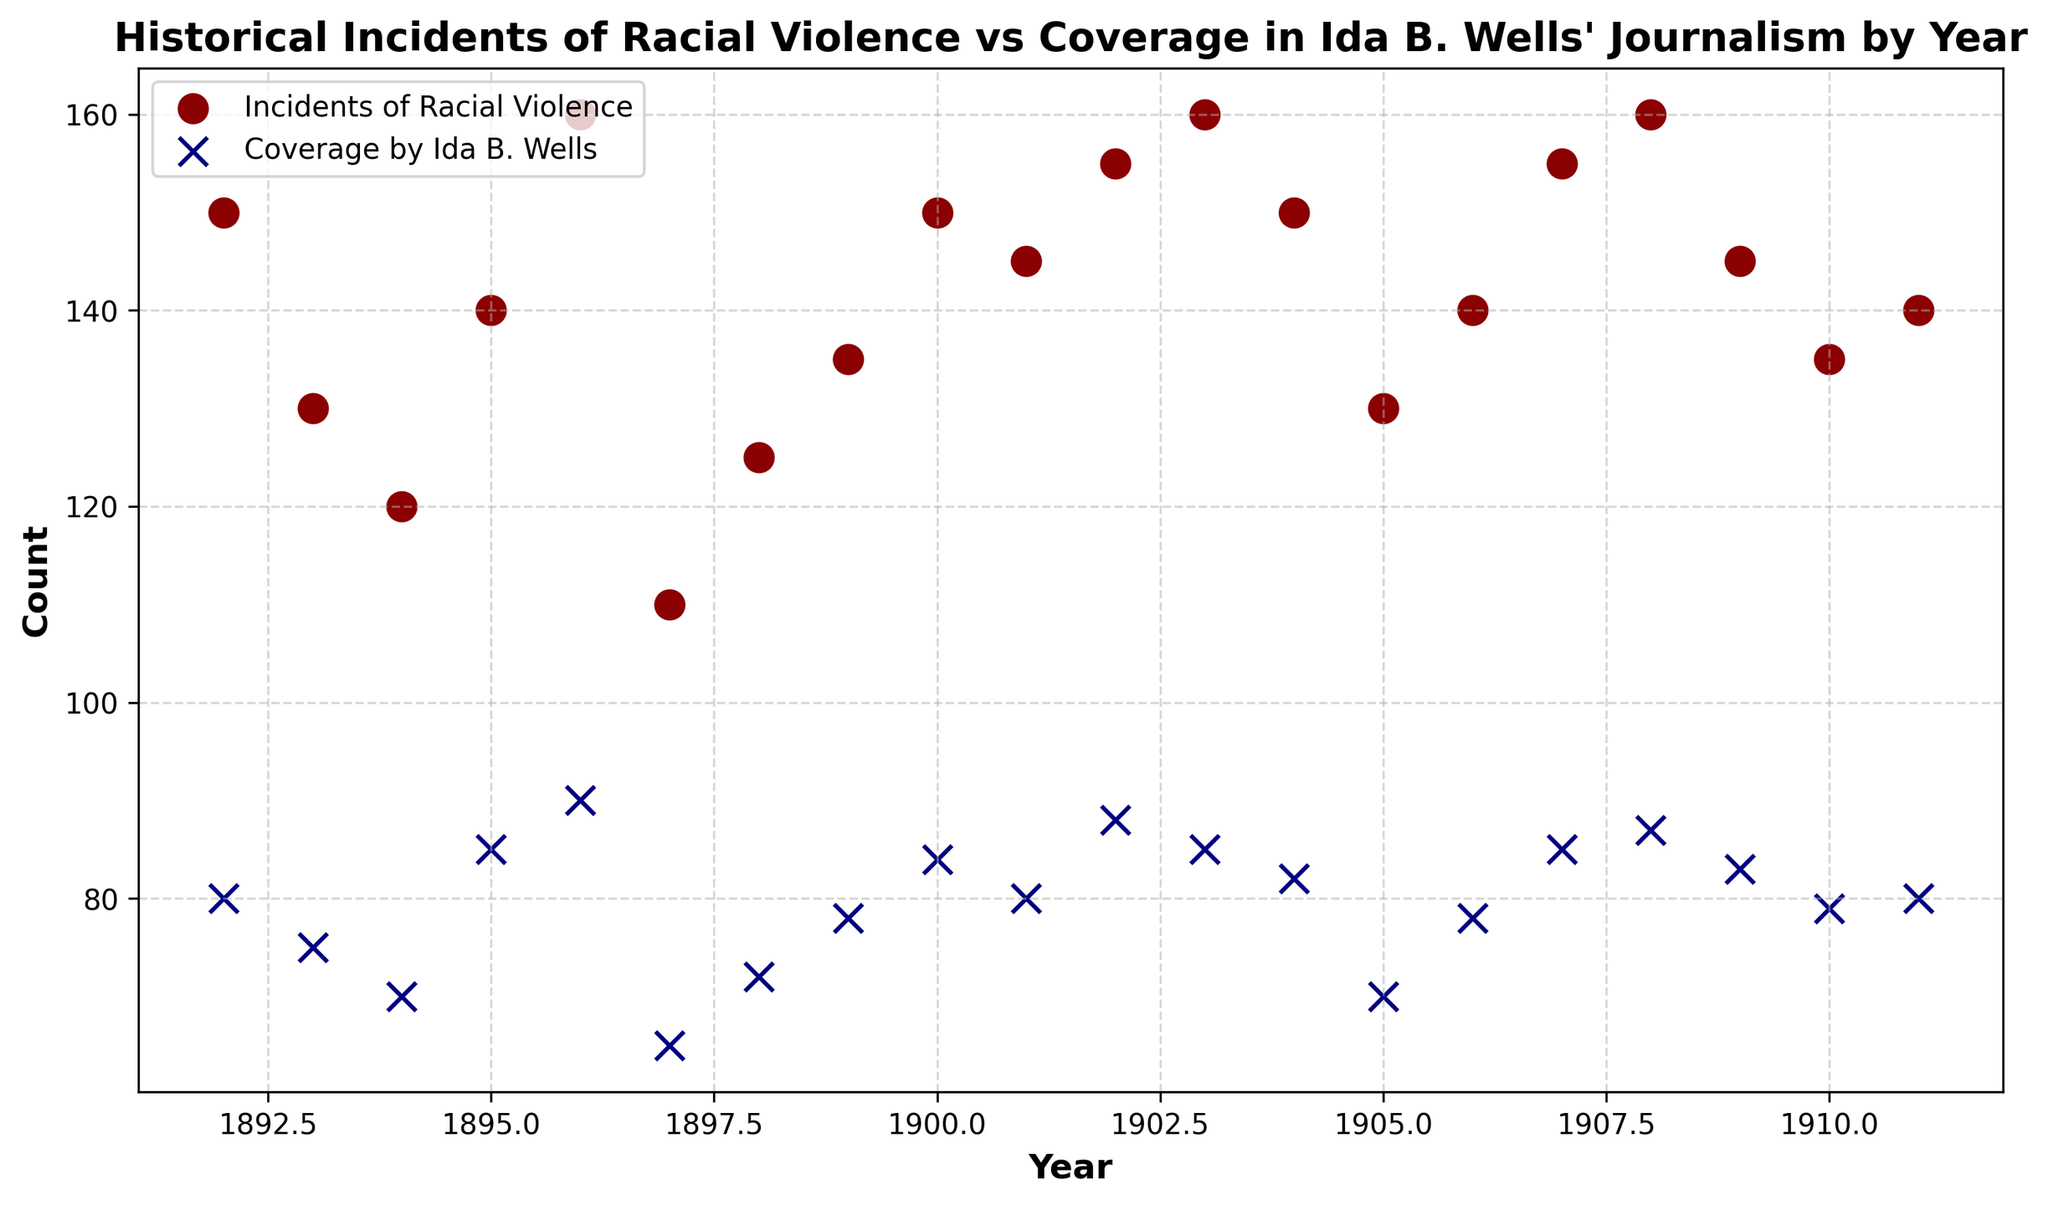What is the highest number of incidents of racial violence in a single year? To find the highest number of incidents of racial violence, observe the "Incidents of Racial Violence" data points on the scatter plot. The highest dot corresponds to 160 incidents, occurring in the years 1896, 1903, 1908.
Answer: 160 In which year did Ida B. Wells' coverage reach its peak? To determine the peak coverage by Ida B. Wells, identify the highest "Coverage by Ida B. Wells" data point on the scatter plot. The peak is marked at 90, which occurred in 1896.
Answer: 1896 How does the number of incidents of racial violence in 1902 compare to the number of incidents in 1900? Compare the "Incidents of Racial Violence" data points for the years 1902 and 1900 on the scatter plot. In 1902, there were 155 incidents, whereas in 1900, there were 150.
Answer: 1902 had more incidents During which two consecutive years did Ida B. Wells' coverage of racial violence decrease? Look for two consecutive years where the "Coverage by Ida B. Wells" points show a downward trend. Between 1895 (85) and 1896 (90) and between 1896 (90) and 1897 (65), there is no decrease. The decrease occurs between 1896 (90) and 1897 (65).
Answer: 1896 and 1897 What is the average coverage by Ida B. Wells from 1906 to 1910? Calculate the average of the "Coverage by Ida B. Wells" data points for the years 1906, 1907, 1908, 1909, and 1910. Add the values: 78 + 85 + 87 + 83 + 79 = 412. Divide by the number of years: 412 / 5 = 82.4.
Answer: 82.4 Which year has the lowest coverage score by Ida B. Wells, and what is the score? Identify the lowest "Coverage by Ida B. Wells" data point on the scatter plot. The lowest value is 65, which occurred in 1897.
Answer: 1897, 65 How did the incidents of racial violence change from 1892 to 1895? Observe the trend of "Incidents of Racial Violence" data points between 1892 and 1895 on the scatter plot. The number decreased from 150 in 1892 to 130 in 1893, to 120 in 1894, then increased to 140 in 1895.
Answer: Initially decreased then increased Is there a year where both incidents of racial violence and Ida B. Wells' coverage were exactly the same? Compare the "Incidents of Racial Violence" and "Coverage by Ida B. Wells" data points year by year. There is no year where both counts are exactly the same.
Answer: No What is the standard deviation of the incidents of racial violence from 1892 to 1911? Locate the incidents of racial violence data points for the years 1892-1911. The values are: 
150, 130, 120, 140, 160, 110, 125, 135, 150, 145, 155, 160, 150, 130, 140, 155, 160, 145, 135, 140. Calculate the mean (sum/20) and then the variance (average of squared differences from the mean), then the square root of the variance gives the standard deviation. Detailed steps are: sum=2835, mean=141.75, variance=sum[(Xi-mean)^2]/20=363.69 and standard deviation=sqrt(variance)=19.07.
Answer: 19.07 Based on the scatter plot, did Ida B. Wells' coverage increase or decrease in 1911 compared to 1910? Compare the "Coverage by Ida B. Wells" data points for 1910 and 1911 on the scatter plot. Coverage remains the same at 80 for both years.
Answer: Stayed the same 